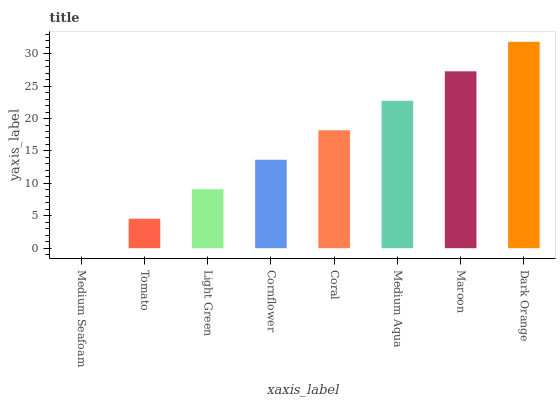Is Tomato the minimum?
Answer yes or no. No. Is Tomato the maximum?
Answer yes or no. No. Is Tomato greater than Medium Seafoam?
Answer yes or no. Yes. Is Medium Seafoam less than Tomato?
Answer yes or no. Yes. Is Medium Seafoam greater than Tomato?
Answer yes or no. No. Is Tomato less than Medium Seafoam?
Answer yes or no. No. Is Coral the high median?
Answer yes or no. Yes. Is Cornflower the low median?
Answer yes or no. Yes. Is Light Green the high median?
Answer yes or no. No. Is Maroon the low median?
Answer yes or no. No. 